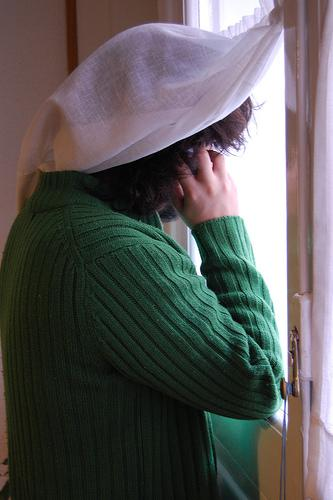Question: where is the woman's right hand?
Choices:
A. In her pocket.
B. In her purse.
C. By her ear.
D. At her side.
Answer with the letter. Answer: C Question: what color is her shirt?
Choices:
A. Green.
B. Blue.
C. Yellow.
D. Red.
Answer with the letter. Answer: A Question: what is on the woman's head?
Choices:
A. A bird.
B. A hairpin.
C. Extensions.
D. Curtain.
Answer with the letter. Answer: D Question: what color is her hair?
Choices:
A. Grey.
B. Brown.
C. Black.
D. Blonde.
Answer with the letter. Answer: B Question: why is the woman's hand by her ear?
Choices:
A. She is putting on earrings.
B. Her ear hurts.
C. Talking on the phone.
D. She is playing with her hair.
Answer with the letter. Answer: C 